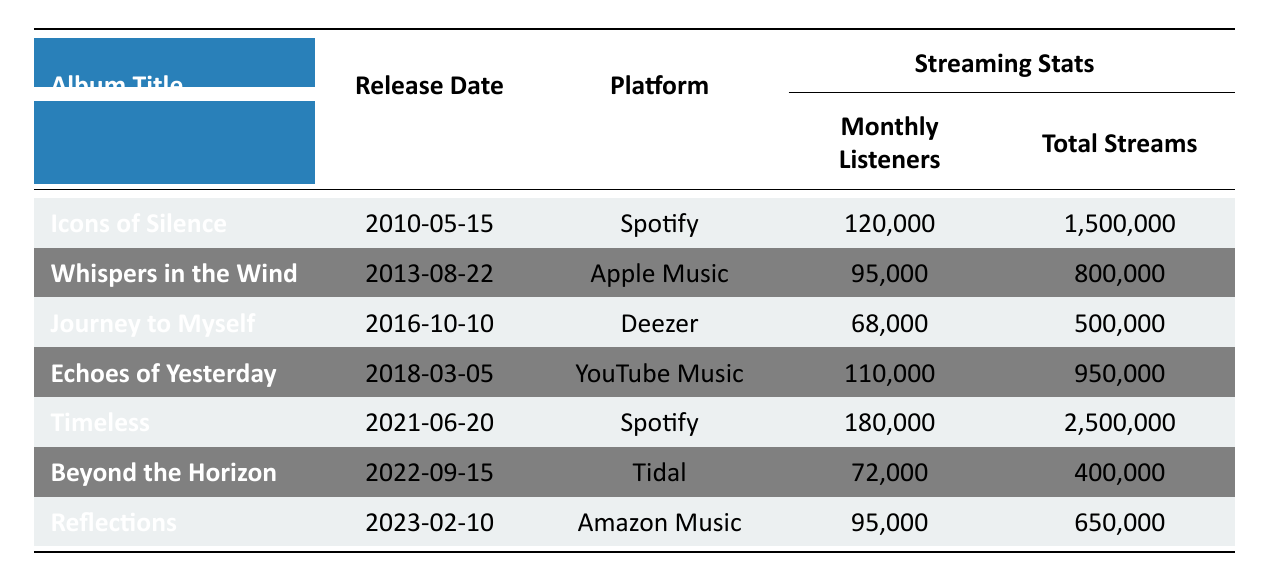What is the release date of "Timeless"? To find the release date, locate "Timeless" in the table and check the corresponding release date column. The date listed is 2021-06-20.
Answer: 2021-06-20 Which album has the highest number of monthly listeners? Compare the monthly listeners for each album. "Timeless" has 180,000 monthly listeners, which is the highest among all albums listed.
Answer: Timeless How many total streams does "Journey to Myself" have? By locating "Journey to Myself" in the table, we see that the total streams listed for this album is 500,000.
Answer: 500,000 What is the average number of monthly listeners across all albums? Calculate the average by adding up the monthly listeners (120,000 + 95,000 + 68,000 + 110,000 + 180,000 + 72,000 + 95,000 = 840,000) and then dividing by the number of albums, which is 7. This gives 840,000 / 7 = 120,000.
Answer: 120,000 Which streaming platform had the lowest total streams? Review the total streams for each album and find the lowest value. "Beyond the Horizon" has the lowest total with 400,000 streams.
Answer: Tidal Is "Whispers in the Wind" streaming on Spotify? Check the table to see which platform "Whispers in the Wind" is listed under; it is on Apple Music, not Spotify.
Answer: No Which album has the most average streams per track? Determine the average streams per track for each album and compare them. "Timeless" has the highest average with 500,000 streams per track.
Answer: Timeless What is the difference in total streams between "Echoes of Yesterday" and "Reflections"? Find the total streams for both albums (Echoes of Yesterday: 950,000; Reflections: 650,000) and calculate the difference: 950,000 - 650,000 = 300,000.
Answer: 300,000 Which albums were released after 2015? Review the release dates and identify albums after 2015: "Echoes of Yesterday" (2018), "Timeless" (2021), "Beyond the Horizon" (2022), and "Reflections" (2023).
Answer: 4 albums What proportion of monthly listeners does "Icons of Silence" have compared to "Timeless"? First, determine the monthly listeners: Icons of Silence has 120,000 and Timeless has 180,000. The proportion is calculated as 120,000 / 180,000 = 0.6667 or about 67%.
Answer: 67% 